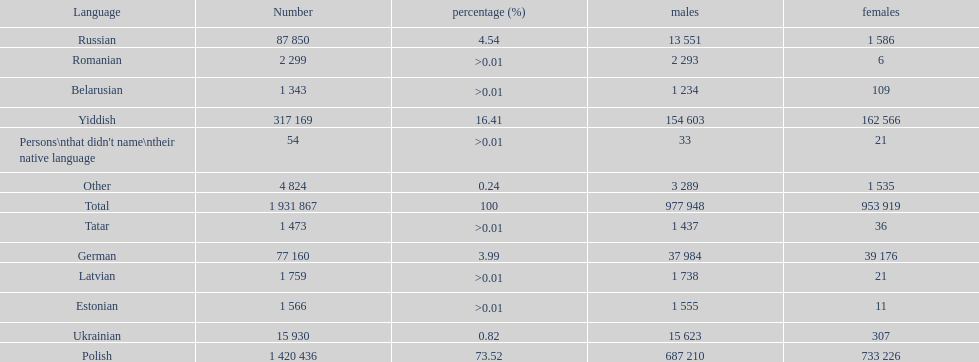Which language had the most number of people speaking it. Polish. 